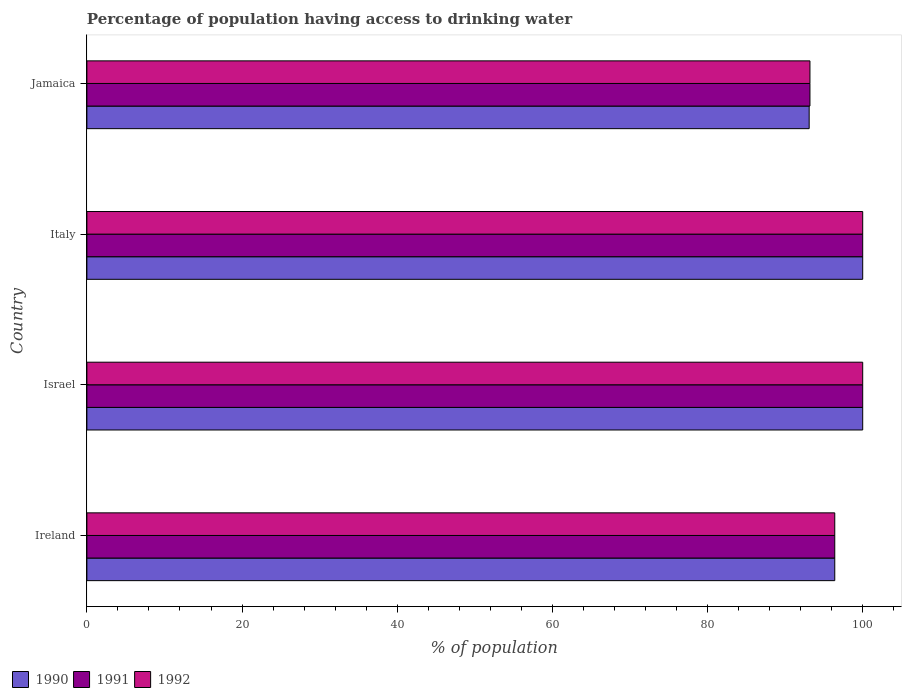How many groups of bars are there?
Provide a short and direct response. 4. Are the number of bars on each tick of the Y-axis equal?
Ensure brevity in your answer.  Yes. How many bars are there on the 3rd tick from the bottom?
Your response must be concise. 3. What is the label of the 3rd group of bars from the top?
Your answer should be compact. Israel. In how many cases, is the number of bars for a given country not equal to the number of legend labels?
Give a very brief answer. 0. What is the percentage of population having access to drinking water in 1990 in Ireland?
Your answer should be compact. 96.4. Across all countries, what is the minimum percentage of population having access to drinking water in 1990?
Offer a terse response. 93.1. In which country was the percentage of population having access to drinking water in 1992 maximum?
Your answer should be very brief. Israel. In which country was the percentage of population having access to drinking water in 1992 minimum?
Provide a succinct answer. Jamaica. What is the total percentage of population having access to drinking water in 1991 in the graph?
Make the answer very short. 389.6. What is the difference between the percentage of population having access to drinking water in 1992 in Ireland and that in Jamaica?
Provide a succinct answer. 3.2. What is the difference between the percentage of population having access to drinking water in 1991 in Israel and the percentage of population having access to drinking water in 1990 in Jamaica?
Ensure brevity in your answer.  6.9. What is the average percentage of population having access to drinking water in 1992 per country?
Keep it short and to the point. 97.4. In how many countries, is the percentage of population having access to drinking water in 1990 greater than 76 %?
Keep it short and to the point. 4. What is the ratio of the percentage of population having access to drinking water in 1992 in Italy to that in Jamaica?
Provide a succinct answer. 1.07. What is the difference between the highest and the lowest percentage of population having access to drinking water in 1990?
Provide a succinct answer. 6.9. In how many countries, is the percentage of population having access to drinking water in 1991 greater than the average percentage of population having access to drinking water in 1991 taken over all countries?
Your answer should be very brief. 2. What does the 1st bar from the top in Italy represents?
Keep it short and to the point. 1992. What does the 1st bar from the bottom in Jamaica represents?
Provide a short and direct response. 1990. Is it the case that in every country, the sum of the percentage of population having access to drinking water in 1991 and percentage of population having access to drinking water in 1990 is greater than the percentage of population having access to drinking water in 1992?
Your response must be concise. Yes. How many countries are there in the graph?
Offer a terse response. 4. Are the values on the major ticks of X-axis written in scientific E-notation?
Make the answer very short. No. Does the graph contain any zero values?
Give a very brief answer. No. Does the graph contain grids?
Your answer should be compact. No. What is the title of the graph?
Keep it short and to the point. Percentage of population having access to drinking water. What is the label or title of the X-axis?
Provide a short and direct response. % of population. What is the % of population in 1990 in Ireland?
Keep it short and to the point. 96.4. What is the % of population of 1991 in Ireland?
Keep it short and to the point. 96.4. What is the % of population of 1992 in Ireland?
Provide a short and direct response. 96.4. What is the % of population of 1992 in Israel?
Your response must be concise. 100. What is the % of population in 1991 in Italy?
Provide a short and direct response. 100. What is the % of population in 1990 in Jamaica?
Your response must be concise. 93.1. What is the % of population of 1991 in Jamaica?
Keep it short and to the point. 93.2. What is the % of population in 1992 in Jamaica?
Give a very brief answer. 93.2. Across all countries, what is the maximum % of population of 1990?
Offer a terse response. 100. Across all countries, what is the maximum % of population in 1991?
Offer a terse response. 100. Across all countries, what is the maximum % of population of 1992?
Ensure brevity in your answer.  100. Across all countries, what is the minimum % of population in 1990?
Offer a terse response. 93.1. Across all countries, what is the minimum % of population of 1991?
Your response must be concise. 93.2. Across all countries, what is the minimum % of population in 1992?
Ensure brevity in your answer.  93.2. What is the total % of population in 1990 in the graph?
Offer a terse response. 389.5. What is the total % of population in 1991 in the graph?
Your response must be concise. 389.6. What is the total % of population of 1992 in the graph?
Your answer should be very brief. 389.6. What is the difference between the % of population in 1990 in Ireland and that in Israel?
Ensure brevity in your answer.  -3.6. What is the difference between the % of population of 1991 in Ireland and that in Israel?
Offer a terse response. -3.6. What is the difference between the % of population of 1990 in Ireland and that in Italy?
Make the answer very short. -3.6. What is the difference between the % of population in 1990 in Ireland and that in Jamaica?
Offer a terse response. 3.3. What is the difference between the % of population in 1991 in Ireland and that in Jamaica?
Your answer should be very brief. 3.2. What is the difference between the % of population in 1992 in Ireland and that in Jamaica?
Offer a terse response. 3.2. What is the difference between the % of population of 1990 in Israel and that in Italy?
Keep it short and to the point. 0. What is the difference between the % of population of 1991 in Israel and that in Italy?
Offer a very short reply. 0. What is the difference between the % of population in 1992 in Israel and that in Italy?
Provide a short and direct response. 0. What is the difference between the % of population in 1990 in Italy and that in Jamaica?
Your response must be concise. 6.9. What is the difference between the % of population in 1990 in Ireland and the % of population in 1991 in Israel?
Offer a very short reply. -3.6. What is the difference between the % of population of 1991 in Ireland and the % of population of 1992 in Israel?
Ensure brevity in your answer.  -3.6. What is the difference between the % of population in 1990 in Ireland and the % of population in 1992 in Jamaica?
Offer a terse response. 3.2. What is the difference between the % of population of 1990 in Israel and the % of population of 1991 in Italy?
Make the answer very short. 0. What is the difference between the % of population of 1990 in Israel and the % of population of 1992 in Italy?
Keep it short and to the point. 0. What is the difference between the % of population of 1991 in Israel and the % of population of 1992 in Italy?
Offer a very short reply. 0. What is the difference between the % of population in 1990 in Israel and the % of population in 1992 in Jamaica?
Your answer should be compact. 6.8. What is the difference between the % of population in 1991 in Israel and the % of population in 1992 in Jamaica?
Your response must be concise. 6.8. What is the difference between the % of population of 1990 in Italy and the % of population of 1992 in Jamaica?
Give a very brief answer. 6.8. What is the difference between the % of population in 1991 in Italy and the % of population in 1992 in Jamaica?
Your answer should be very brief. 6.8. What is the average % of population in 1990 per country?
Your answer should be compact. 97.38. What is the average % of population of 1991 per country?
Your response must be concise. 97.4. What is the average % of population in 1992 per country?
Your answer should be very brief. 97.4. What is the difference between the % of population in 1990 and % of population in 1991 in Ireland?
Your response must be concise. 0. What is the difference between the % of population in 1990 and % of population in 1992 in Ireland?
Your answer should be very brief. 0. What is the difference between the % of population of 1991 and % of population of 1992 in Israel?
Your answer should be very brief. 0. What is the difference between the % of population of 1990 and % of population of 1991 in Italy?
Your answer should be compact. 0. What is the difference between the % of population of 1990 and % of population of 1992 in Italy?
Give a very brief answer. 0. What is the difference between the % of population of 1990 and % of population of 1991 in Jamaica?
Make the answer very short. -0.1. What is the difference between the % of population of 1991 and % of population of 1992 in Jamaica?
Keep it short and to the point. 0. What is the ratio of the % of population of 1990 in Ireland to that in Israel?
Make the answer very short. 0.96. What is the ratio of the % of population of 1992 in Ireland to that in Israel?
Offer a very short reply. 0.96. What is the ratio of the % of population in 1990 in Ireland to that in Italy?
Keep it short and to the point. 0.96. What is the ratio of the % of population in 1991 in Ireland to that in Italy?
Keep it short and to the point. 0.96. What is the ratio of the % of population of 1990 in Ireland to that in Jamaica?
Your response must be concise. 1.04. What is the ratio of the % of population in 1991 in Ireland to that in Jamaica?
Ensure brevity in your answer.  1.03. What is the ratio of the % of population of 1992 in Ireland to that in Jamaica?
Your answer should be very brief. 1.03. What is the ratio of the % of population in 1990 in Israel to that in Italy?
Keep it short and to the point. 1. What is the ratio of the % of population of 1991 in Israel to that in Italy?
Offer a very short reply. 1. What is the ratio of the % of population of 1990 in Israel to that in Jamaica?
Give a very brief answer. 1.07. What is the ratio of the % of population in 1991 in Israel to that in Jamaica?
Make the answer very short. 1.07. What is the ratio of the % of population of 1992 in Israel to that in Jamaica?
Your response must be concise. 1.07. What is the ratio of the % of population of 1990 in Italy to that in Jamaica?
Offer a terse response. 1.07. What is the ratio of the % of population in 1991 in Italy to that in Jamaica?
Provide a succinct answer. 1.07. What is the ratio of the % of population of 1992 in Italy to that in Jamaica?
Your answer should be very brief. 1.07. What is the difference between the highest and the second highest % of population of 1991?
Your answer should be very brief. 0. What is the difference between the highest and the second highest % of population in 1992?
Give a very brief answer. 0. What is the difference between the highest and the lowest % of population of 1990?
Offer a terse response. 6.9. 